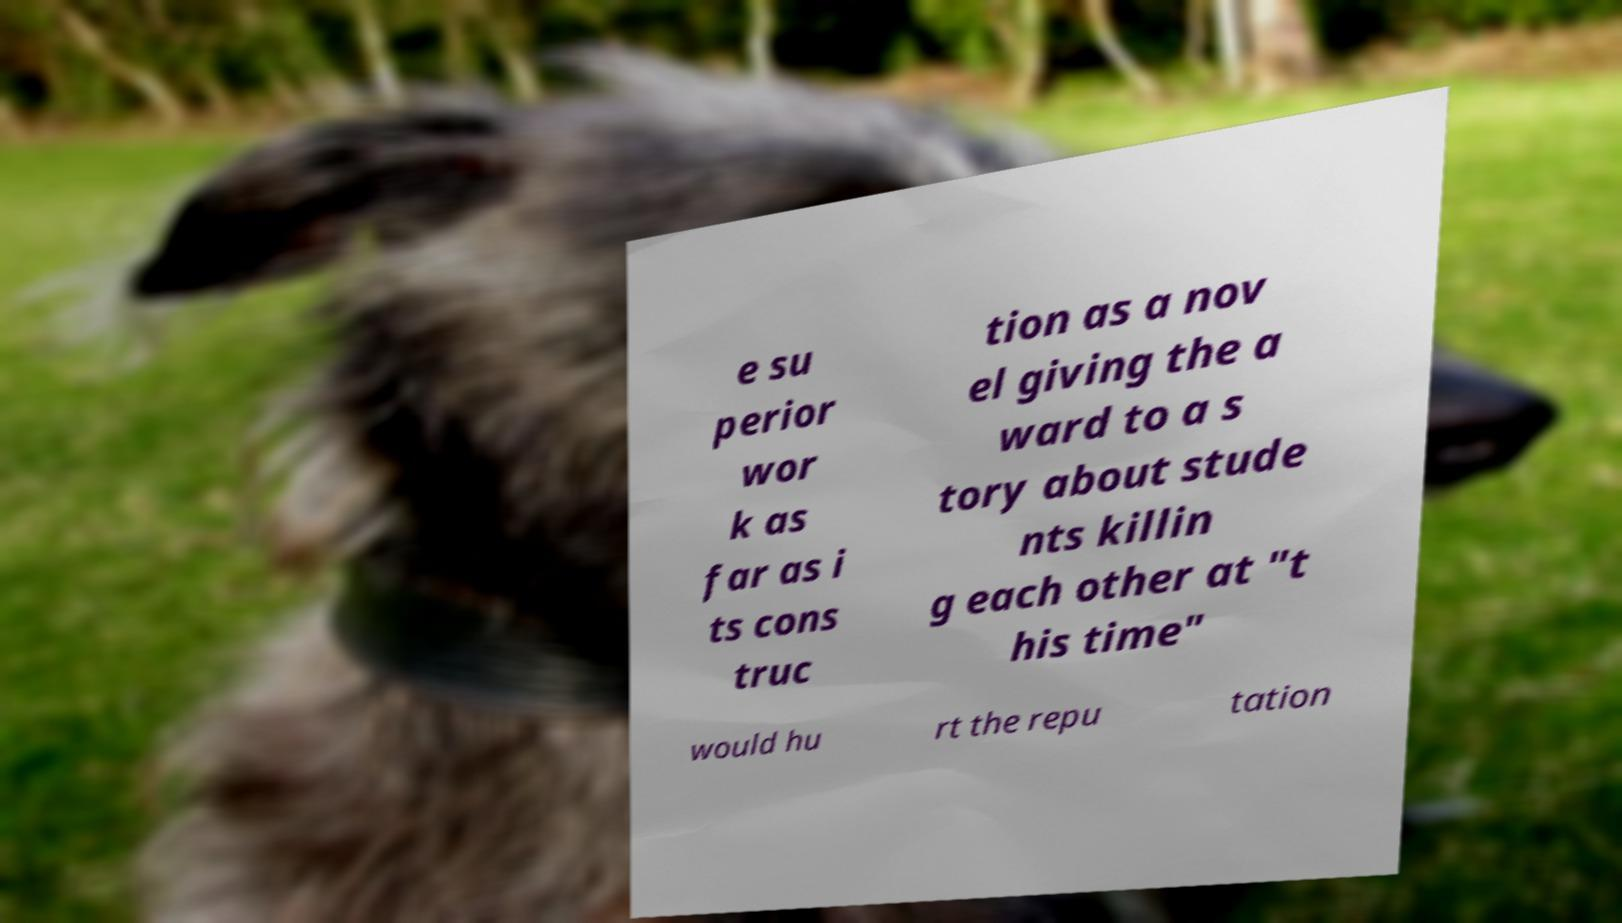Could you assist in decoding the text presented in this image and type it out clearly? e su perior wor k as far as i ts cons truc tion as a nov el giving the a ward to a s tory about stude nts killin g each other at "t his time" would hu rt the repu tation 